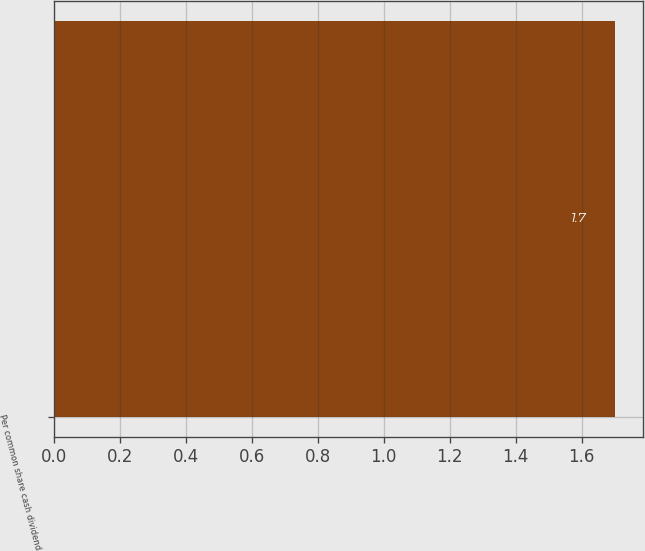Convert chart. <chart><loc_0><loc_0><loc_500><loc_500><bar_chart><fcel>Per common share cash dividend<nl><fcel>1.7<nl></chart> 